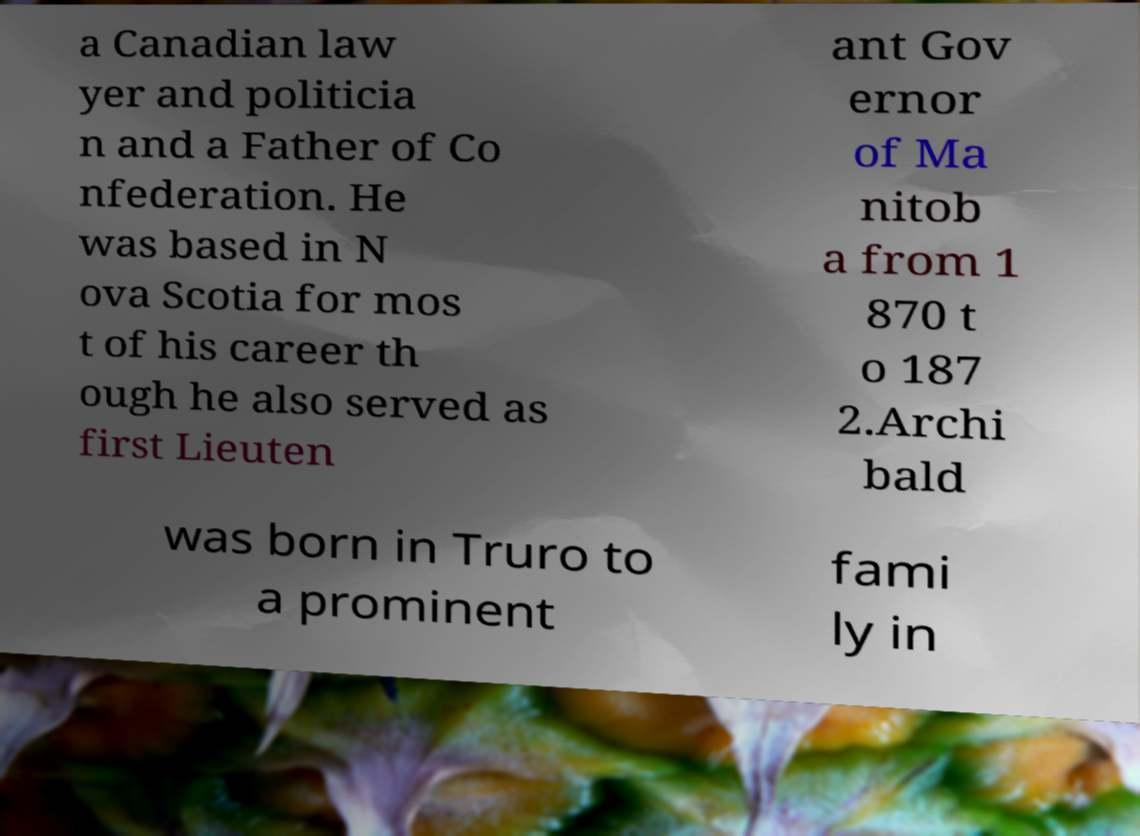Can you accurately transcribe the text from the provided image for me? a Canadian law yer and politicia n and a Father of Co nfederation. He was based in N ova Scotia for mos t of his career th ough he also served as first Lieuten ant Gov ernor of Ma nitob a from 1 870 t o 187 2.Archi bald was born in Truro to a prominent fami ly in 